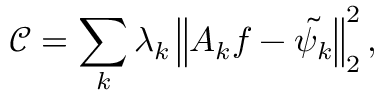Convert formula to latex. <formula><loc_0><loc_0><loc_500><loc_500>\mathcal { C } = \sum _ { k } \lambda _ { k } \left \| A _ { k } f - \tilde { \psi _ { k } } \right \| _ { 2 } ^ { 2 } ,</formula> 